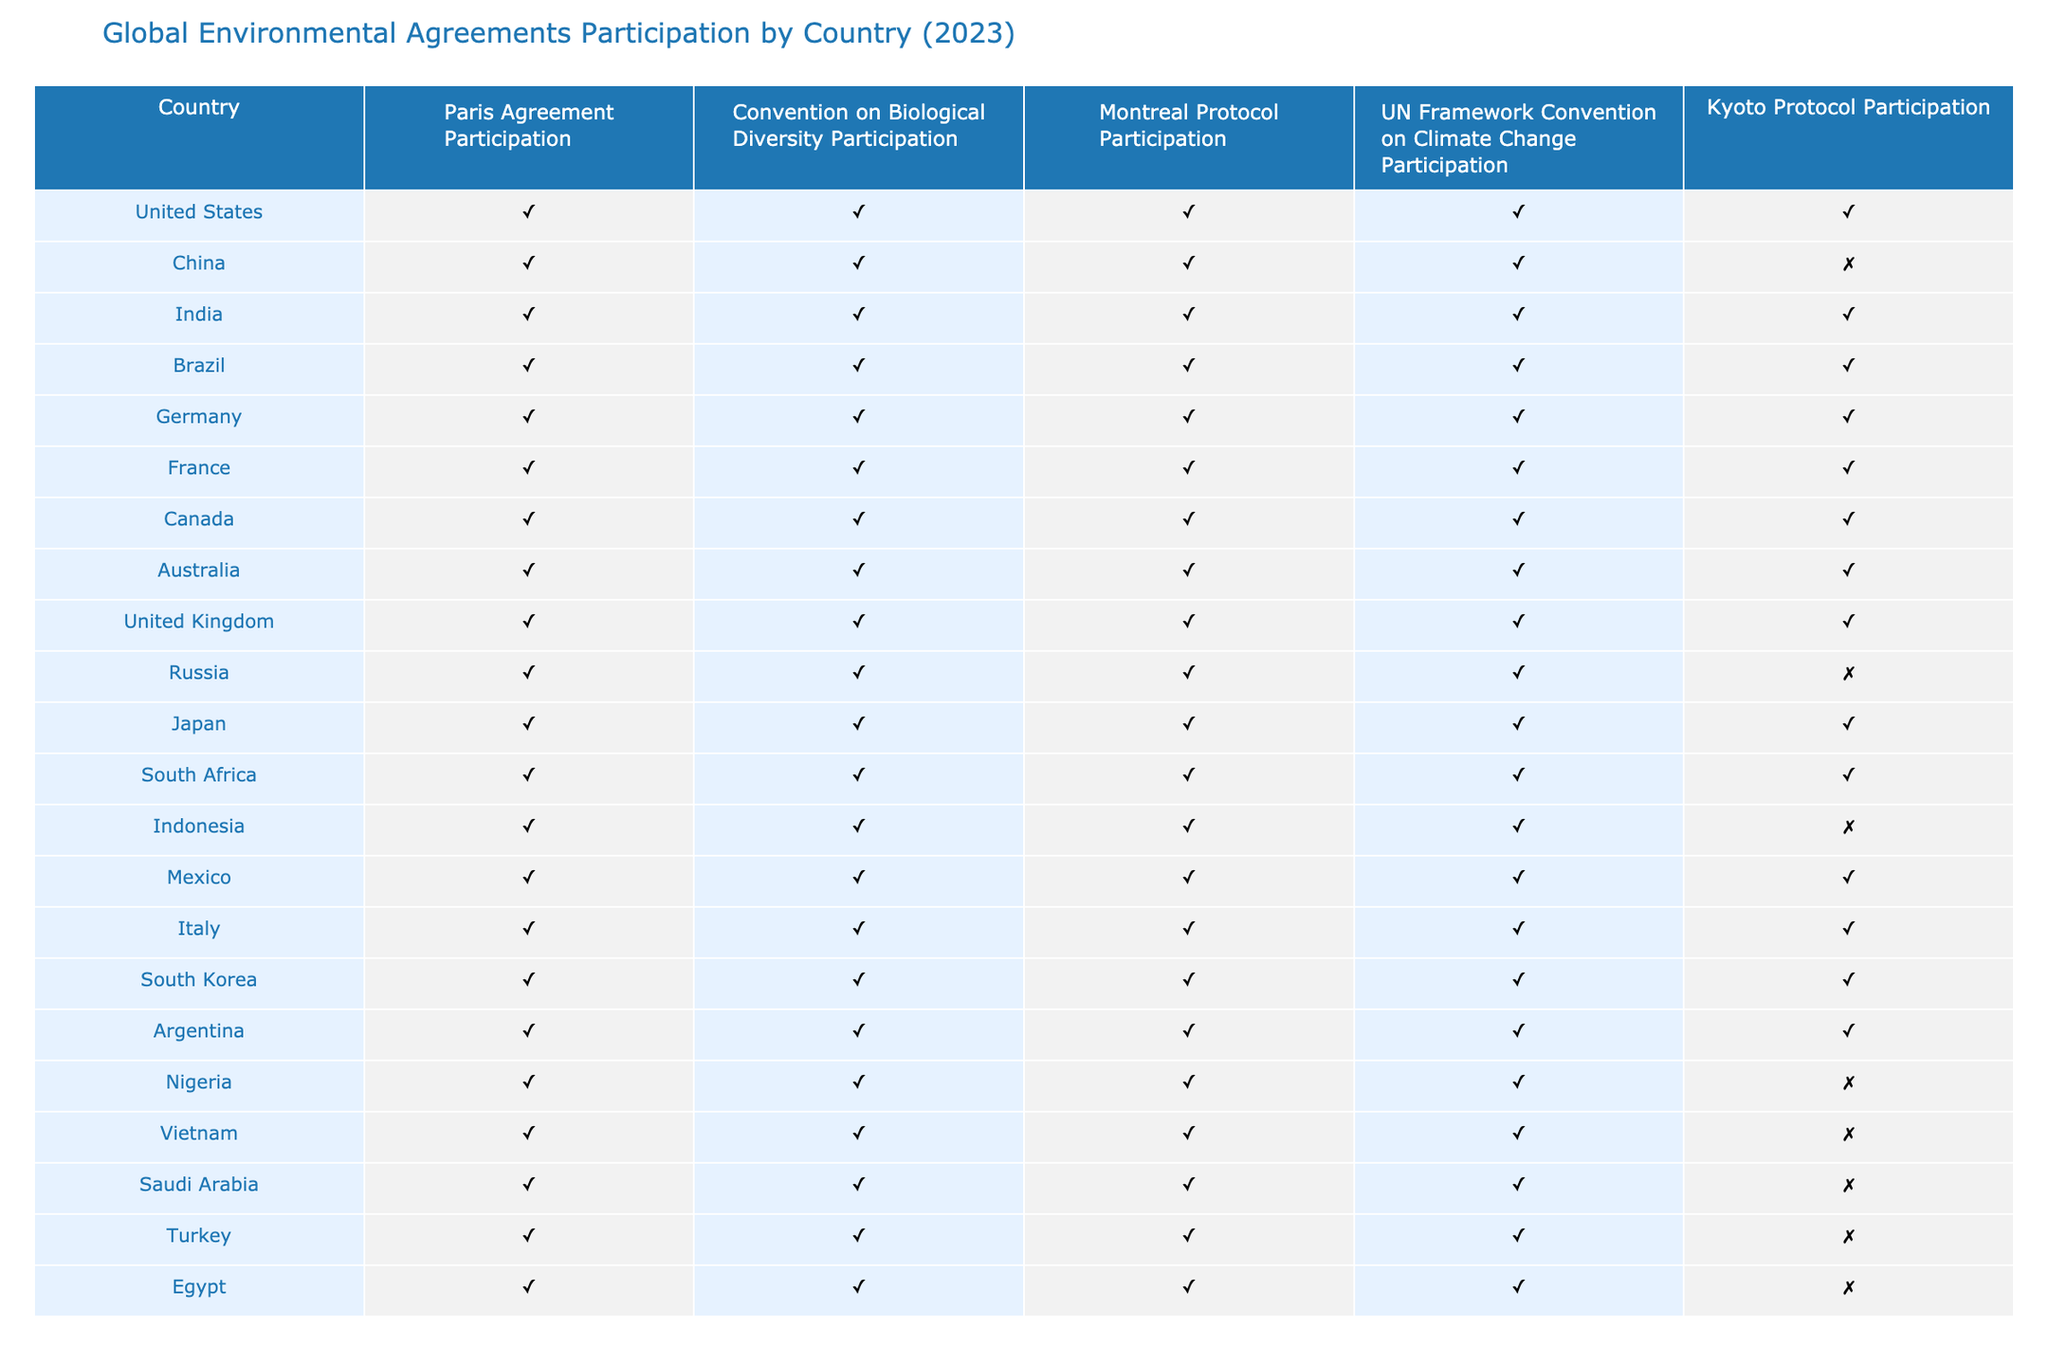What countries are participating in the Paris Agreement? By looking at the "Paris Agreement Participation" column, we can see that all the countries listed have marked "Yes" for participation.
Answer: All countries Which country is not participating in the Kyoto Protocol? The "Kyoto Protocol Participation" column shows that China, Russia, Indonesia, Nigeria, Vietnam, Saudi Arabia, and Turkey have marked "No."
Answer: China, Russia, Indonesia, Nigeria, Vietnam, Saudi Arabia, Turkey How many countries are participating in all five agreements? We need to check each country's participation across all columns. By reviewing the table, India, Brazil, Germany, France, Canada, Australia, Japan, South Africa, Italy, and South Korea have participation marked as "Yes" in all five agreements.
Answer: 10 Is Russia participating in the Kyoto Protocol? By examining the row for Russia in the "Kyoto Protocol Participation" column, it is marked as "No."
Answer: No Which countries participate in the Convention on Biological Diversity but not in the Kyoto Protocol? We can cross-reference the "Convention on Biological Diversity Participation" and "Kyoto Protocol Participation" columns. The countries participating in the Convention but not in the Kyoto Protocol are China, Russia, Indonesia, Nigeria, Vietnam, Saudi Arabia, and Turkey.
Answer: China, Russia, Indonesia, Nigeria, Vietnam, Saudi Arabia, Turkey How many countries are participating in the UN Framework Convention on Climate Change? We look at the "UN Framework Convention on Climate Change Participation" column, where all countries have "Yes" marked. Thus, there are as many participating countries as there are listed.
Answer: 20 Are there any countries in the table that participate in the Paris Agreement but not in the Montreal Protocol? Examining the "Paris Agreement Participation" column and comparing it with the "Montreal Protocol Participation" column reveals that all countries listed participate in both.
Answer: No If we divide the total number of countries participating in the Paris Agreement (20) by those not participating in the Kyoto Protocol (7), what is the result? There are 20 countries in total; among them, 7 are not participating in the Kyoto Protocol. We divide 20 by 7, which gives us roughly 2.86.
Answer: Approximately 2.86 Which country has participated in all agreements except the Kyoto Protocol? A review of the table indicates that China and Russia have "No" in the Kyoto Protocol but "Yes" in all others.
Answer: China, Russia How many countries are participating in the Montreal Protocol? The data shows that all countries have marked participation as "Yes" for the Montreal Protocol. Thus, we count all listed countries.
Answer: 20 